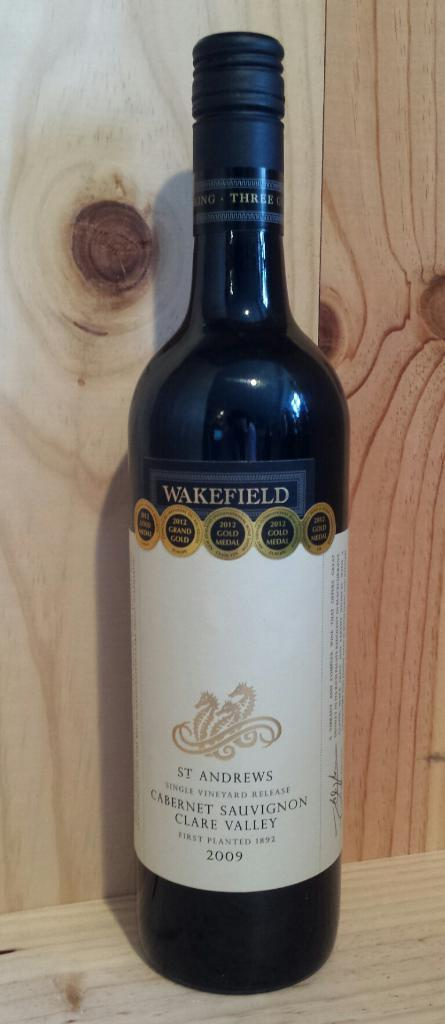<image>
Provide a brief description of the given image. a bottle with the word wakefield on it 